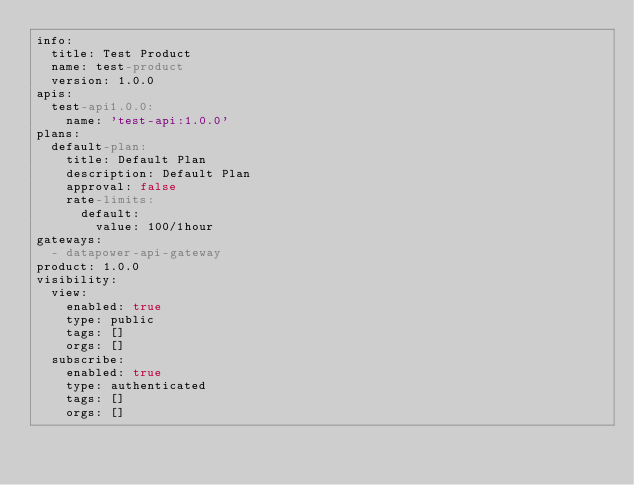Convert code to text. <code><loc_0><loc_0><loc_500><loc_500><_YAML_>info:
  title: Test Product
  name: test-product
  version: 1.0.0
apis:
  test-api1.0.0:
    name: 'test-api:1.0.0'
plans:
  default-plan:
    title: Default Plan
    description: Default Plan
    approval: false
    rate-limits:
      default:
        value: 100/1hour
gateways:
  - datapower-api-gateway
product: 1.0.0
visibility:
  view:
    enabled: true
    type: public
    tags: []
    orgs: []
  subscribe:
    enabled: true
    type: authenticated
    tags: []
    orgs: []
</code> 